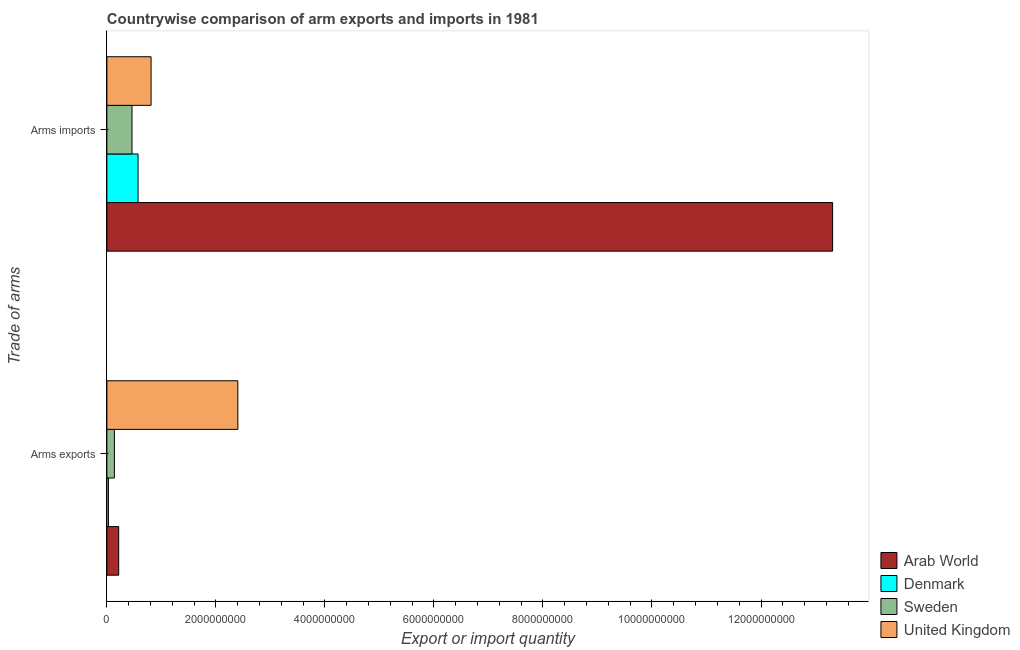How many groups of bars are there?
Ensure brevity in your answer.  2. Are the number of bars per tick equal to the number of legend labels?
Offer a very short reply. Yes. Are the number of bars on each tick of the Y-axis equal?
Provide a succinct answer. Yes. How many bars are there on the 1st tick from the top?
Keep it short and to the point. 4. What is the label of the 1st group of bars from the top?
Your answer should be compact. Arms imports. What is the arms exports in Arab World?
Provide a succinct answer. 2.17e+08. Across all countries, what is the maximum arms imports?
Offer a terse response. 1.33e+1. Across all countries, what is the minimum arms exports?
Offer a very short reply. 2.90e+07. In which country was the arms exports maximum?
Ensure brevity in your answer.  United Kingdom. In which country was the arms imports minimum?
Your answer should be compact. Sweden. What is the total arms imports in the graph?
Give a very brief answer. 1.52e+1. What is the difference between the arms exports in Denmark and that in Arab World?
Offer a terse response. -1.88e+08. What is the difference between the arms imports in Denmark and the arms exports in Arab World?
Make the answer very short. 3.55e+08. What is the average arms imports per country?
Keep it short and to the point. 3.79e+09. What is the difference between the arms exports and arms imports in Arab World?
Ensure brevity in your answer.  -1.31e+1. What is the ratio of the arms exports in Sweden to that in Denmark?
Keep it short and to the point. 4.76. What does the 4th bar from the top in Arms imports represents?
Your response must be concise. Arab World. What does the 3rd bar from the bottom in Arms exports represents?
Your answer should be compact. Sweden. How many bars are there?
Give a very brief answer. 8. Are all the bars in the graph horizontal?
Your answer should be compact. Yes. How many countries are there in the graph?
Ensure brevity in your answer.  4. What is the difference between two consecutive major ticks on the X-axis?
Provide a succinct answer. 2.00e+09. Are the values on the major ticks of X-axis written in scientific E-notation?
Offer a terse response. No. How are the legend labels stacked?
Your answer should be compact. Vertical. What is the title of the graph?
Provide a succinct answer. Countrywise comparison of arm exports and imports in 1981. What is the label or title of the X-axis?
Your answer should be compact. Export or import quantity. What is the label or title of the Y-axis?
Provide a short and direct response. Trade of arms. What is the Export or import quantity of Arab World in Arms exports?
Your answer should be very brief. 2.17e+08. What is the Export or import quantity of Denmark in Arms exports?
Your answer should be very brief. 2.90e+07. What is the Export or import quantity in Sweden in Arms exports?
Your answer should be compact. 1.38e+08. What is the Export or import quantity of United Kingdom in Arms exports?
Ensure brevity in your answer.  2.40e+09. What is the Export or import quantity of Arab World in Arms imports?
Ensure brevity in your answer.  1.33e+1. What is the Export or import quantity of Denmark in Arms imports?
Your answer should be very brief. 5.72e+08. What is the Export or import quantity in Sweden in Arms imports?
Your response must be concise. 4.61e+08. What is the Export or import quantity in United Kingdom in Arms imports?
Provide a short and direct response. 8.11e+08. Across all Trade of arms, what is the maximum Export or import quantity of Arab World?
Provide a succinct answer. 1.33e+1. Across all Trade of arms, what is the maximum Export or import quantity in Denmark?
Offer a very short reply. 5.72e+08. Across all Trade of arms, what is the maximum Export or import quantity in Sweden?
Your response must be concise. 4.61e+08. Across all Trade of arms, what is the maximum Export or import quantity of United Kingdom?
Make the answer very short. 2.40e+09. Across all Trade of arms, what is the minimum Export or import quantity of Arab World?
Ensure brevity in your answer.  2.17e+08. Across all Trade of arms, what is the minimum Export or import quantity of Denmark?
Give a very brief answer. 2.90e+07. Across all Trade of arms, what is the minimum Export or import quantity in Sweden?
Your response must be concise. 1.38e+08. Across all Trade of arms, what is the minimum Export or import quantity in United Kingdom?
Ensure brevity in your answer.  8.11e+08. What is the total Export or import quantity in Arab World in the graph?
Provide a short and direct response. 1.35e+1. What is the total Export or import quantity of Denmark in the graph?
Keep it short and to the point. 6.01e+08. What is the total Export or import quantity of Sweden in the graph?
Provide a short and direct response. 5.99e+08. What is the total Export or import quantity in United Kingdom in the graph?
Keep it short and to the point. 3.21e+09. What is the difference between the Export or import quantity of Arab World in Arms exports and that in Arms imports?
Offer a very short reply. -1.31e+1. What is the difference between the Export or import quantity in Denmark in Arms exports and that in Arms imports?
Your answer should be very brief. -5.43e+08. What is the difference between the Export or import quantity in Sweden in Arms exports and that in Arms imports?
Keep it short and to the point. -3.23e+08. What is the difference between the Export or import quantity in United Kingdom in Arms exports and that in Arms imports?
Your answer should be very brief. 1.59e+09. What is the difference between the Export or import quantity of Arab World in Arms exports and the Export or import quantity of Denmark in Arms imports?
Ensure brevity in your answer.  -3.55e+08. What is the difference between the Export or import quantity in Arab World in Arms exports and the Export or import quantity in Sweden in Arms imports?
Your answer should be very brief. -2.44e+08. What is the difference between the Export or import quantity of Arab World in Arms exports and the Export or import quantity of United Kingdom in Arms imports?
Provide a succinct answer. -5.94e+08. What is the difference between the Export or import quantity in Denmark in Arms exports and the Export or import quantity in Sweden in Arms imports?
Give a very brief answer. -4.32e+08. What is the difference between the Export or import quantity in Denmark in Arms exports and the Export or import quantity in United Kingdom in Arms imports?
Your answer should be compact. -7.82e+08. What is the difference between the Export or import quantity in Sweden in Arms exports and the Export or import quantity in United Kingdom in Arms imports?
Give a very brief answer. -6.73e+08. What is the average Export or import quantity in Arab World per Trade of arms?
Make the answer very short. 6.77e+09. What is the average Export or import quantity of Denmark per Trade of arms?
Offer a very short reply. 3.00e+08. What is the average Export or import quantity of Sweden per Trade of arms?
Provide a short and direct response. 3.00e+08. What is the average Export or import quantity of United Kingdom per Trade of arms?
Offer a very short reply. 1.61e+09. What is the difference between the Export or import quantity of Arab World and Export or import quantity of Denmark in Arms exports?
Keep it short and to the point. 1.88e+08. What is the difference between the Export or import quantity of Arab World and Export or import quantity of Sweden in Arms exports?
Offer a terse response. 7.90e+07. What is the difference between the Export or import quantity of Arab World and Export or import quantity of United Kingdom in Arms exports?
Provide a succinct answer. -2.19e+09. What is the difference between the Export or import quantity in Denmark and Export or import quantity in Sweden in Arms exports?
Offer a very short reply. -1.09e+08. What is the difference between the Export or import quantity of Denmark and Export or import quantity of United Kingdom in Arms exports?
Ensure brevity in your answer.  -2.37e+09. What is the difference between the Export or import quantity in Sweden and Export or import quantity in United Kingdom in Arms exports?
Make the answer very short. -2.26e+09. What is the difference between the Export or import quantity of Arab World and Export or import quantity of Denmark in Arms imports?
Ensure brevity in your answer.  1.27e+1. What is the difference between the Export or import quantity in Arab World and Export or import quantity in Sweden in Arms imports?
Make the answer very short. 1.29e+1. What is the difference between the Export or import quantity in Arab World and Export or import quantity in United Kingdom in Arms imports?
Your answer should be compact. 1.25e+1. What is the difference between the Export or import quantity in Denmark and Export or import quantity in Sweden in Arms imports?
Offer a very short reply. 1.11e+08. What is the difference between the Export or import quantity in Denmark and Export or import quantity in United Kingdom in Arms imports?
Ensure brevity in your answer.  -2.39e+08. What is the difference between the Export or import quantity in Sweden and Export or import quantity in United Kingdom in Arms imports?
Offer a very short reply. -3.50e+08. What is the ratio of the Export or import quantity in Arab World in Arms exports to that in Arms imports?
Provide a succinct answer. 0.02. What is the ratio of the Export or import quantity in Denmark in Arms exports to that in Arms imports?
Offer a very short reply. 0.05. What is the ratio of the Export or import quantity of Sweden in Arms exports to that in Arms imports?
Your answer should be compact. 0.3. What is the ratio of the Export or import quantity in United Kingdom in Arms exports to that in Arms imports?
Provide a short and direct response. 2.96. What is the difference between the highest and the second highest Export or import quantity of Arab World?
Make the answer very short. 1.31e+1. What is the difference between the highest and the second highest Export or import quantity of Denmark?
Ensure brevity in your answer.  5.43e+08. What is the difference between the highest and the second highest Export or import quantity of Sweden?
Your answer should be compact. 3.23e+08. What is the difference between the highest and the second highest Export or import quantity in United Kingdom?
Provide a succinct answer. 1.59e+09. What is the difference between the highest and the lowest Export or import quantity of Arab World?
Your answer should be very brief. 1.31e+1. What is the difference between the highest and the lowest Export or import quantity in Denmark?
Your answer should be compact. 5.43e+08. What is the difference between the highest and the lowest Export or import quantity in Sweden?
Provide a short and direct response. 3.23e+08. What is the difference between the highest and the lowest Export or import quantity in United Kingdom?
Provide a short and direct response. 1.59e+09. 